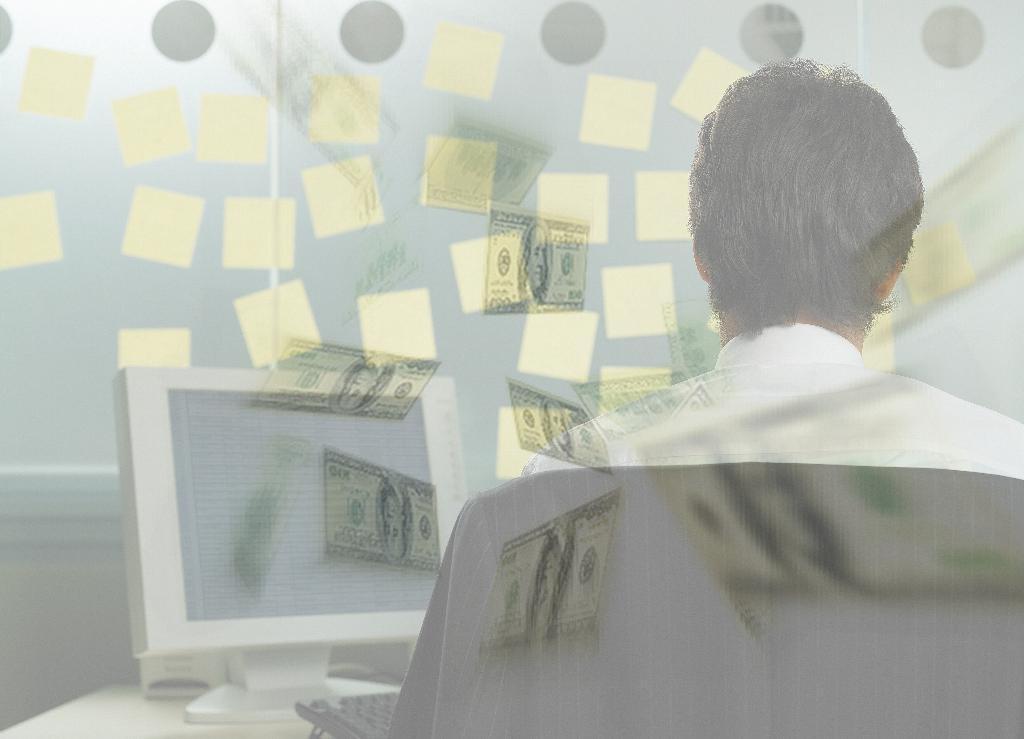Can you describe this image briefly? In this picture I can observe a computer placed on the table on the left side. On the right side I can observe a man sitting on the chair. I can observe currency notes in the middle of the picture. 